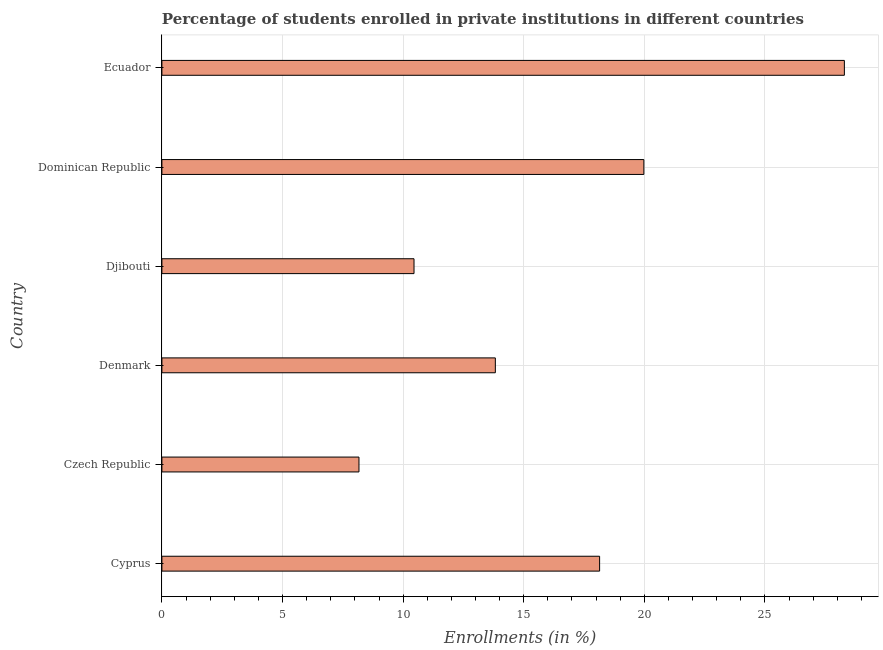Does the graph contain grids?
Offer a very short reply. Yes. What is the title of the graph?
Offer a terse response. Percentage of students enrolled in private institutions in different countries. What is the label or title of the X-axis?
Make the answer very short. Enrollments (in %). What is the enrollments in private institutions in Czech Republic?
Your answer should be compact. 8.17. Across all countries, what is the maximum enrollments in private institutions?
Keep it short and to the point. 28.29. Across all countries, what is the minimum enrollments in private institutions?
Your answer should be compact. 8.17. In which country was the enrollments in private institutions maximum?
Your response must be concise. Ecuador. In which country was the enrollments in private institutions minimum?
Ensure brevity in your answer.  Czech Republic. What is the sum of the enrollments in private institutions?
Offer a very short reply. 98.86. What is the difference between the enrollments in private institutions in Djibouti and Ecuador?
Your response must be concise. -17.84. What is the average enrollments in private institutions per country?
Offer a very short reply. 16.48. What is the median enrollments in private institutions?
Your answer should be compact. 15.98. In how many countries, is the enrollments in private institutions greater than 3 %?
Provide a short and direct response. 6. What is the ratio of the enrollments in private institutions in Djibouti to that in Ecuador?
Offer a terse response. 0.37. Is the enrollments in private institutions in Denmark less than that in Dominican Republic?
Ensure brevity in your answer.  Yes. Is the difference between the enrollments in private institutions in Djibouti and Ecuador greater than the difference between any two countries?
Make the answer very short. No. What is the difference between the highest and the second highest enrollments in private institutions?
Your answer should be very brief. 8.31. Is the sum of the enrollments in private institutions in Czech Republic and Denmark greater than the maximum enrollments in private institutions across all countries?
Your response must be concise. No. What is the difference between the highest and the lowest enrollments in private institutions?
Offer a terse response. 20.12. In how many countries, is the enrollments in private institutions greater than the average enrollments in private institutions taken over all countries?
Make the answer very short. 3. Are all the bars in the graph horizontal?
Your answer should be compact. Yes. How many countries are there in the graph?
Provide a succinct answer. 6. Are the values on the major ticks of X-axis written in scientific E-notation?
Your response must be concise. No. What is the Enrollments (in %) of Cyprus?
Ensure brevity in your answer.  18.15. What is the Enrollments (in %) in Czech Republic?
Your answer should be compact. 8.17. What is the Enrollments (in %) in Denmark?
Keep it short and to the point. 13.82. What is the Enrollments (in %) of Djibouti?
Make the answer very short. 10.45. What is the Enrollments (in %) in Dominican Republic?
Your answer should be very brief. 19.98. What is the Enrollments (in %) of Ecuador?
Ensure brevity in your answer.  28.29. What is the difference between the Enrollments (in %) in Cyprus and Czech Republic?
Your answer should be very brief. 9.98. What is the difference between the Enrollments (in %) in Cyprus and Denmark?
Provide a succinct answer. 4.32. What is the difference between the Enrollments (in %) in Cyprus and Djibouti?
Your answer should be very brief. 7.69. What is the difference between the Enrollments (in %) in Cyprus and Dominican Republic?
Offer a terse response. -1.83. What is the difference between the Enrollments (in %) in Cyprus and Ecuador?
Your response must be concise. -10.15. What is the difference between the Enrollments (in %) in Czech Republic and Denmark?
Your answer should be compact. -5.65. What is the difference between the Enrollments (in %) in Czech Republic and Djibouti?
Provide a short and direct response. -2.28. What is the difference between the Enrollments (in %) in Czech Republic and Dominican Republic?
Give a very brief answer. -11.81. What is the difference between the Enrollments (in %) in Czech Republic and Ecuador?
Offer a terse response. -20.12. What is the difference between the Enrollments (in %) in Denmark and Djibouti?
Your answer should be compact. 3.37. What is the difference between the Enrollments (in %) in Denmark and Dominican Republic?
Ensure brevity in your answer.  -6.16. What is the difference between the Enrollments (in %) in Denmark and Ecuador?
Your answer should be very brief. -14.47. What is the difference between the Enrollments (in %) in Djibouti and Dominican Republic?
Offer a very short reply. -9.53. What is the difference between the Enrollments (in %) in Djibouti and Ecuador?
Offer a very short reply. -17.84. What is the difference between the Enrollments (in %) in Dominican Republic and Ecuador?
Your answer should be very brief. -8.31. What is the ratio of the Enrollments (in %) in Cyprus to that in Czech Republic?
Your answer should be very brief. 2.22. What is the ratio of the Enrollments (in %) in Cyprus to that in Denmark?
Your response must be concise. 1.31. What is the ratio of the Enrollments (in %) in Cyprus to that in Djibouti?
Keep it short and to the point. 1.74. What is the ratio of the Enrollments (in %) in Cyprus to that in Dominican Republic?
Ensure brevity in your answer.  0.91. What is the ratio of the Enrollments (in %) in Cyprus to that in Ecuador?
Offer a terse response. 0.64. What is the ratio of the Enrollments (in %) in Czech Republic to that in Denmark?
Make the answer very short. 0.59. What is the ratio of the Enrollments (in %) in Czech Republic to that in Djibouti?
Offer a terse response. 0.78. What is the ratio of the Enrollments (in %) in Czech Republic to that in Dominican Republic?
Give a very brief answer. 0.41. What is the ratio of the Enrollments (in %) in Czech Republic to that in Ecuador?
Give a very brief answer. 0.29. What is the ratio of the Enrollments (in %) in Denmark to that in Djibouti?
Ensure brevity in your answer.  1.32. What is the ratio of the Enrollments (in %) in Denmark to that in Dominican Republic?
Provide a short and direct response. 0.69. What is the ratio of the Enrollments (in %) in Denmark to that in Ecuador?
Make the answer very short. 0.49. What is the ratio of the Enrollments (in %) in Djibouti to that in Dominican Republic?
Your response must be concise. 0.52. What is the ratio of the Enrollments (in %) in Djibouti to that in Ecuador?
Offer a terse response. 0.37. What is the ratio of the Enrollments (in %) in Dominican Republic to that in Ecuador?
Your answer should be very brief. 0.71. 